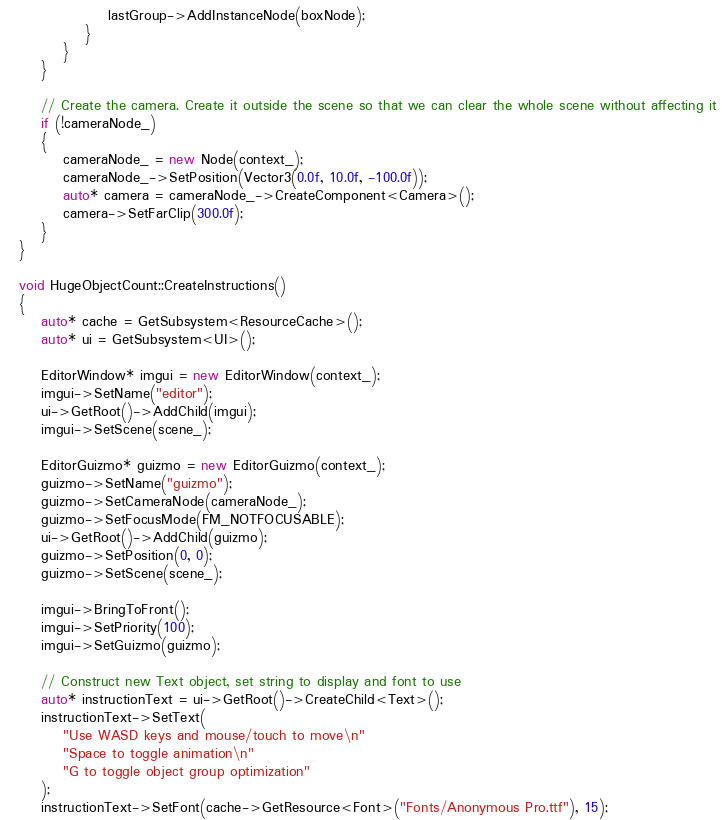<code> <loc_0><loc_0><loc_500><loc_500><_C++_>                lastGroup->AddInstanceNode(boxNode);
            }
        }
    }

    // Create the camera. Create it outside the scene so that we can clear the whole scene without affecting it
    if (!cameraNode_)
    {
        cameraNode_ = new Node(context_);
        cameraNode_->SetPosition(Vector3(0.0f, 10.0f, -100.0f));
        auto* camera = cameraNode_->CreateComponent<Camera>();
        camera->SetFarClip(300.0f);
    }
}

void HugeObjectCount::CreateInstructions()
{
    auto* cache = GetSubsystem<ResourceCache>();
    auto* ui = GetSubsystem<UI>();

    EditorWindow* imgui = new EditorWindow(context_);
    imgui->SetName("editor");
    ui->GetRoot()->AddChild(imgui);
    imgui->SetScene(scene_);

    EditorGuizmo* guizmo = new EditorGuizmo(context_);
    guizmo->SetName("guizmo");
    guizmo->SetCameraNode(cameraNode_);
    guizmo->SetFocusMode(FM_NOTFOCUSABLE);
    ui->GetRoot()->AddChild(guizmo);
    guizmo->SetPosition(0, 0);
    guizmo->SetScene(scene_);

    imgui->BringToFront();
    imgui->SetPriority(100);
    imgui->SetGuizmo(guizmo);

    // Construct new Text object, set string to display and font to use
    auto* instructionText = ui->GetRoot()->CreateChild<Text>();
    instructionText->SetText(
        "Use WASD keys and mouse/touch to move\n"
        "Space to toggle animation\n"
        "G to toggle object group optimization"
    );
    instructionText->SetFont(cache->GetResource<Font>("Fonts/Anonymous Pro.ttf"), 15);</code> 